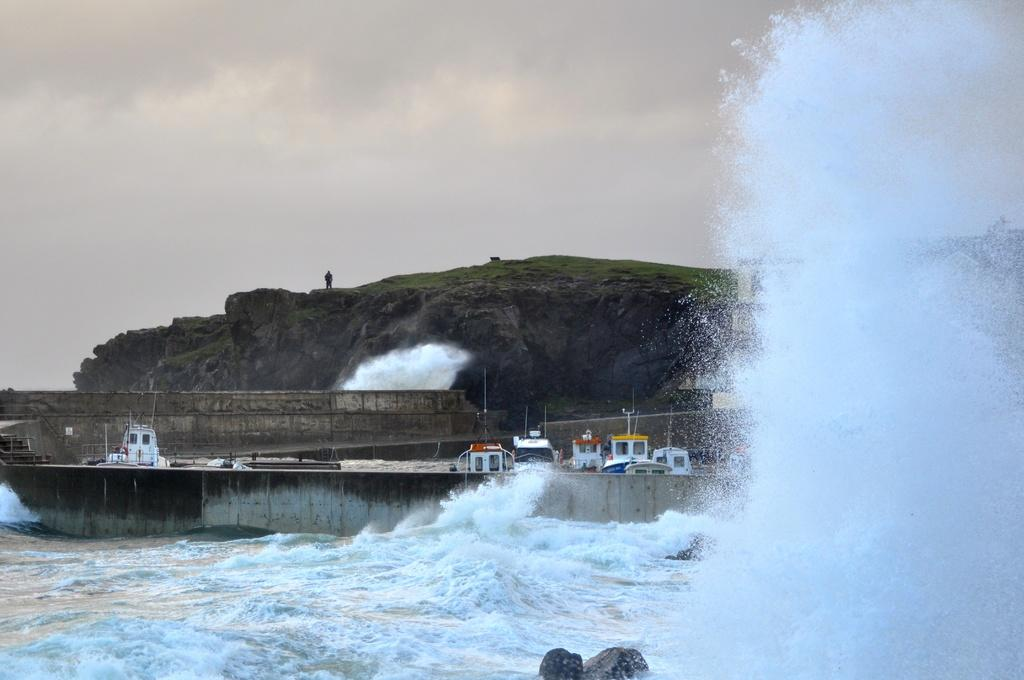What is the main feature in the foreground of the image? There is a giant tide in the foreground of the image. What can be seen in the water in the foreground? There are rocks in the water in the foreground. What is visible in the background of the image? There are ships near the dock and a cliff in the background. Can you describe the person in the image? A man is standing on the cliff in the background. What is the weather like in the image? The presence of clouds visible in the background suggests that it might be partly cloudy. How many ants can be seen carrying the muscle in the image? There are no ants or muscles present in the image. What type of yard is visible in the image? There is no yard visible in the image; it features a giant tide, rocks, ships, a cliff, and a man. 